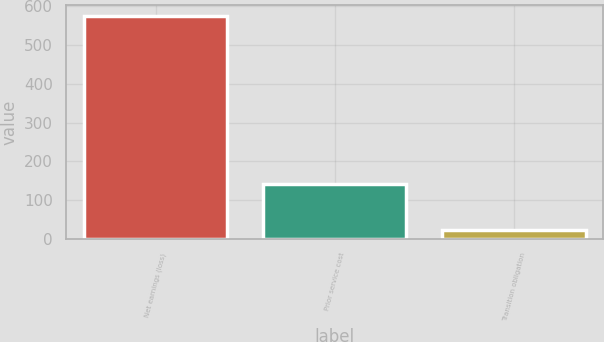Convert chart to OTSL. <chart><loc_0><loc_0><loc_500><loc_500><bar_chart><fcel>Net earnings (loss)<fcel>Prior service cost<fcel>Transition obligation<nl><fcel>574<fcel>141<fcel>23<nl></chart> 